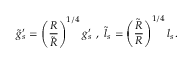Convert formula to latex. <formula><loc_0><loc_0><loc_500><loc_500>\tilde { g } _ { s } ^ { \prime } = \left ( \frac { R } { \tilde { R } } \right ) ^ { 1 / 4 } g _ { s } ^ { \prime } \ , \ \tilde { l } _ { s } = \left ( \frac { \tilde { R } } { R } \right ) ^ { 1 / 4 } l _ { s } .</formula> 